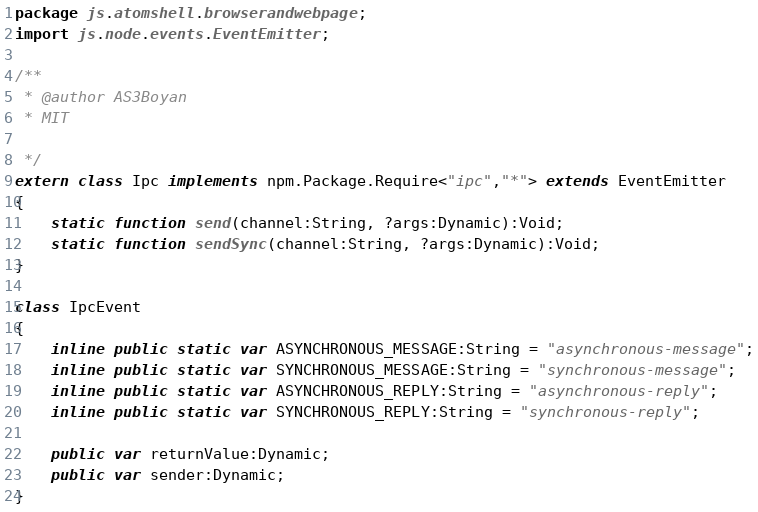<code> <loc_0><loc_0><loc_500><loc_500><_Haxe_>package js.atomshell.browserandwebpage;
import js.node.events.EventEmitter;

/**
 * @author AS3Boyan
 * MIT

 */
extern class Ipc implements npm.Package.Require<"ipc","*"> extends EventEmitter
{
	static function send(channel:String, ?args:Dynamic):Void;
	static function sendSync(channel:String, ?args:Dynamic):Void;
}

class IpcEvent
{
	inline public static var ASYNCHRONOUS_MESSAGE:String = "asynchronous-message";
	inline public static var SYNCHRONOUS_MESSAGE:String = "synchronous-message";
	inline public static var ASYNCHRONOUS_REPLY:String = "asynchronous-reply";
	inline public static var SYNCHRONOUS_REPLY:String = "synchronous-reply";
	
	public var returnValue:Dynamic;
	public var sender:Dynamic;
}</code> 